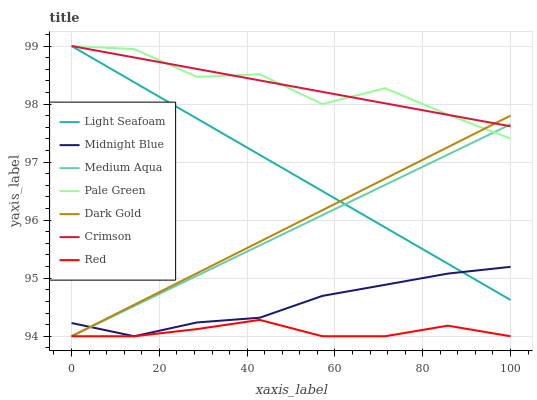Does Red have the minimum area under the curve?
Answer yes or no. Yes. Does Pale Green have the maximum area under the curve?
Answer yes or no. Yes. Does Dark Gold have the minimum area under the curve?
Answer yes or no. No. Does Dark Gold have the maximum area under the curve?
Answer yes or no. No. Is Light Seafoam the smoothest?
Answer yes or no. Yes. Is Pale Green the roughest?
Answer yes or no. Yes. Is Dark Gold the smoothest?
Answer yes or no. No. Is Dark Gold the roughest?
Answer yes or no. No. Does Midnight Blue have the lowest value?
Answer yes or no. Yes. Does Pale Green have the lowest value?
Answer yes or no. No. Does Light Seafoam have the highest value?
Answer yes or no. Yes. Does Dark Gold have the highest value?
Answer yes or no. No. Is Red less than Pale Green?
Answer yes or no. Yes. Is Crimson greater than Midnight Blue?
Answer yes or no. Yes. Does Midnight Blue intersect Medium Aqua?
Answer yes or no. Yes. Is Midnight Blue less than Medium Aqua?
Answer yes or no. No. Is Midnight Blue greater than Medium Aqua?
Answer yes or no. No. Does Red intersect Pale Green?
Answer yes or no. No. 